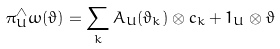Convert formula to latex. <formula><loc_0><loc_0><loc_500><loc_500>\pi _ { U } ^ { \wedge } \omega ( \vartheta ) = \sum _ { k } A _ { U } ( \vartheta _ { k } ) \otimes c _ { k } + 1 _ { U } \otimes \vartheta</formula> 